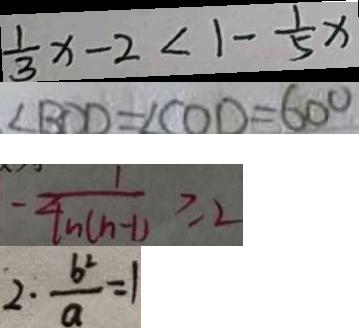Convert formula to latex. <formula><loc_0><loc_0><loc_500><loc_500>\frac { 1 } { 3 } x - 2 < 1 - \frac { 1 } { 5 } x 
 \angle B C D = \angle C O D = 6 0 ^ { \circ } 
 - \frac { 1 } { 4 n ( n - 1 ) } \geq 2 
 2 \cdot \frac { b ^ { 2 } } { a } = 1</formula> 